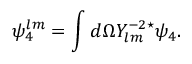<formula> <loc_0><loc_0><loc_500><loc_500>\psi _ { 4 } ^ { l m } = \int d \Omega Y _ { l m } ^ { - 2 ^ { * } } \psi _ { 4 } .</formula> 